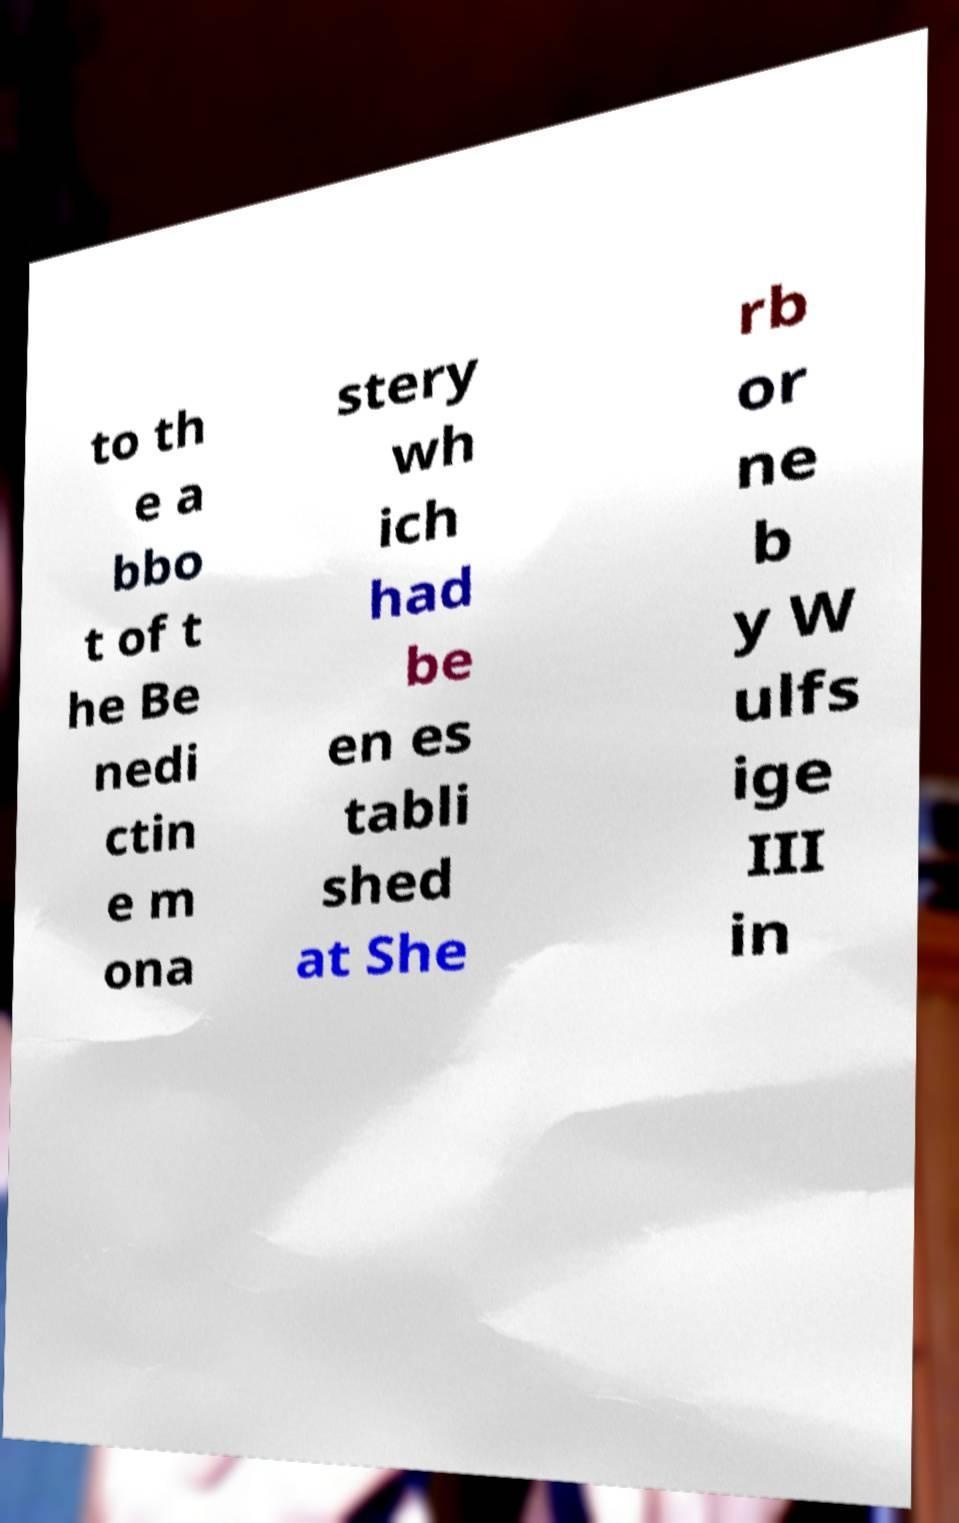Please read and relay the text visible in this image. What does it say? to th e a bbo t of t he Be nedi ctin e m ona stery wh ich had be en es tabli shed at She rb or ne b y W ulfs ige III in 